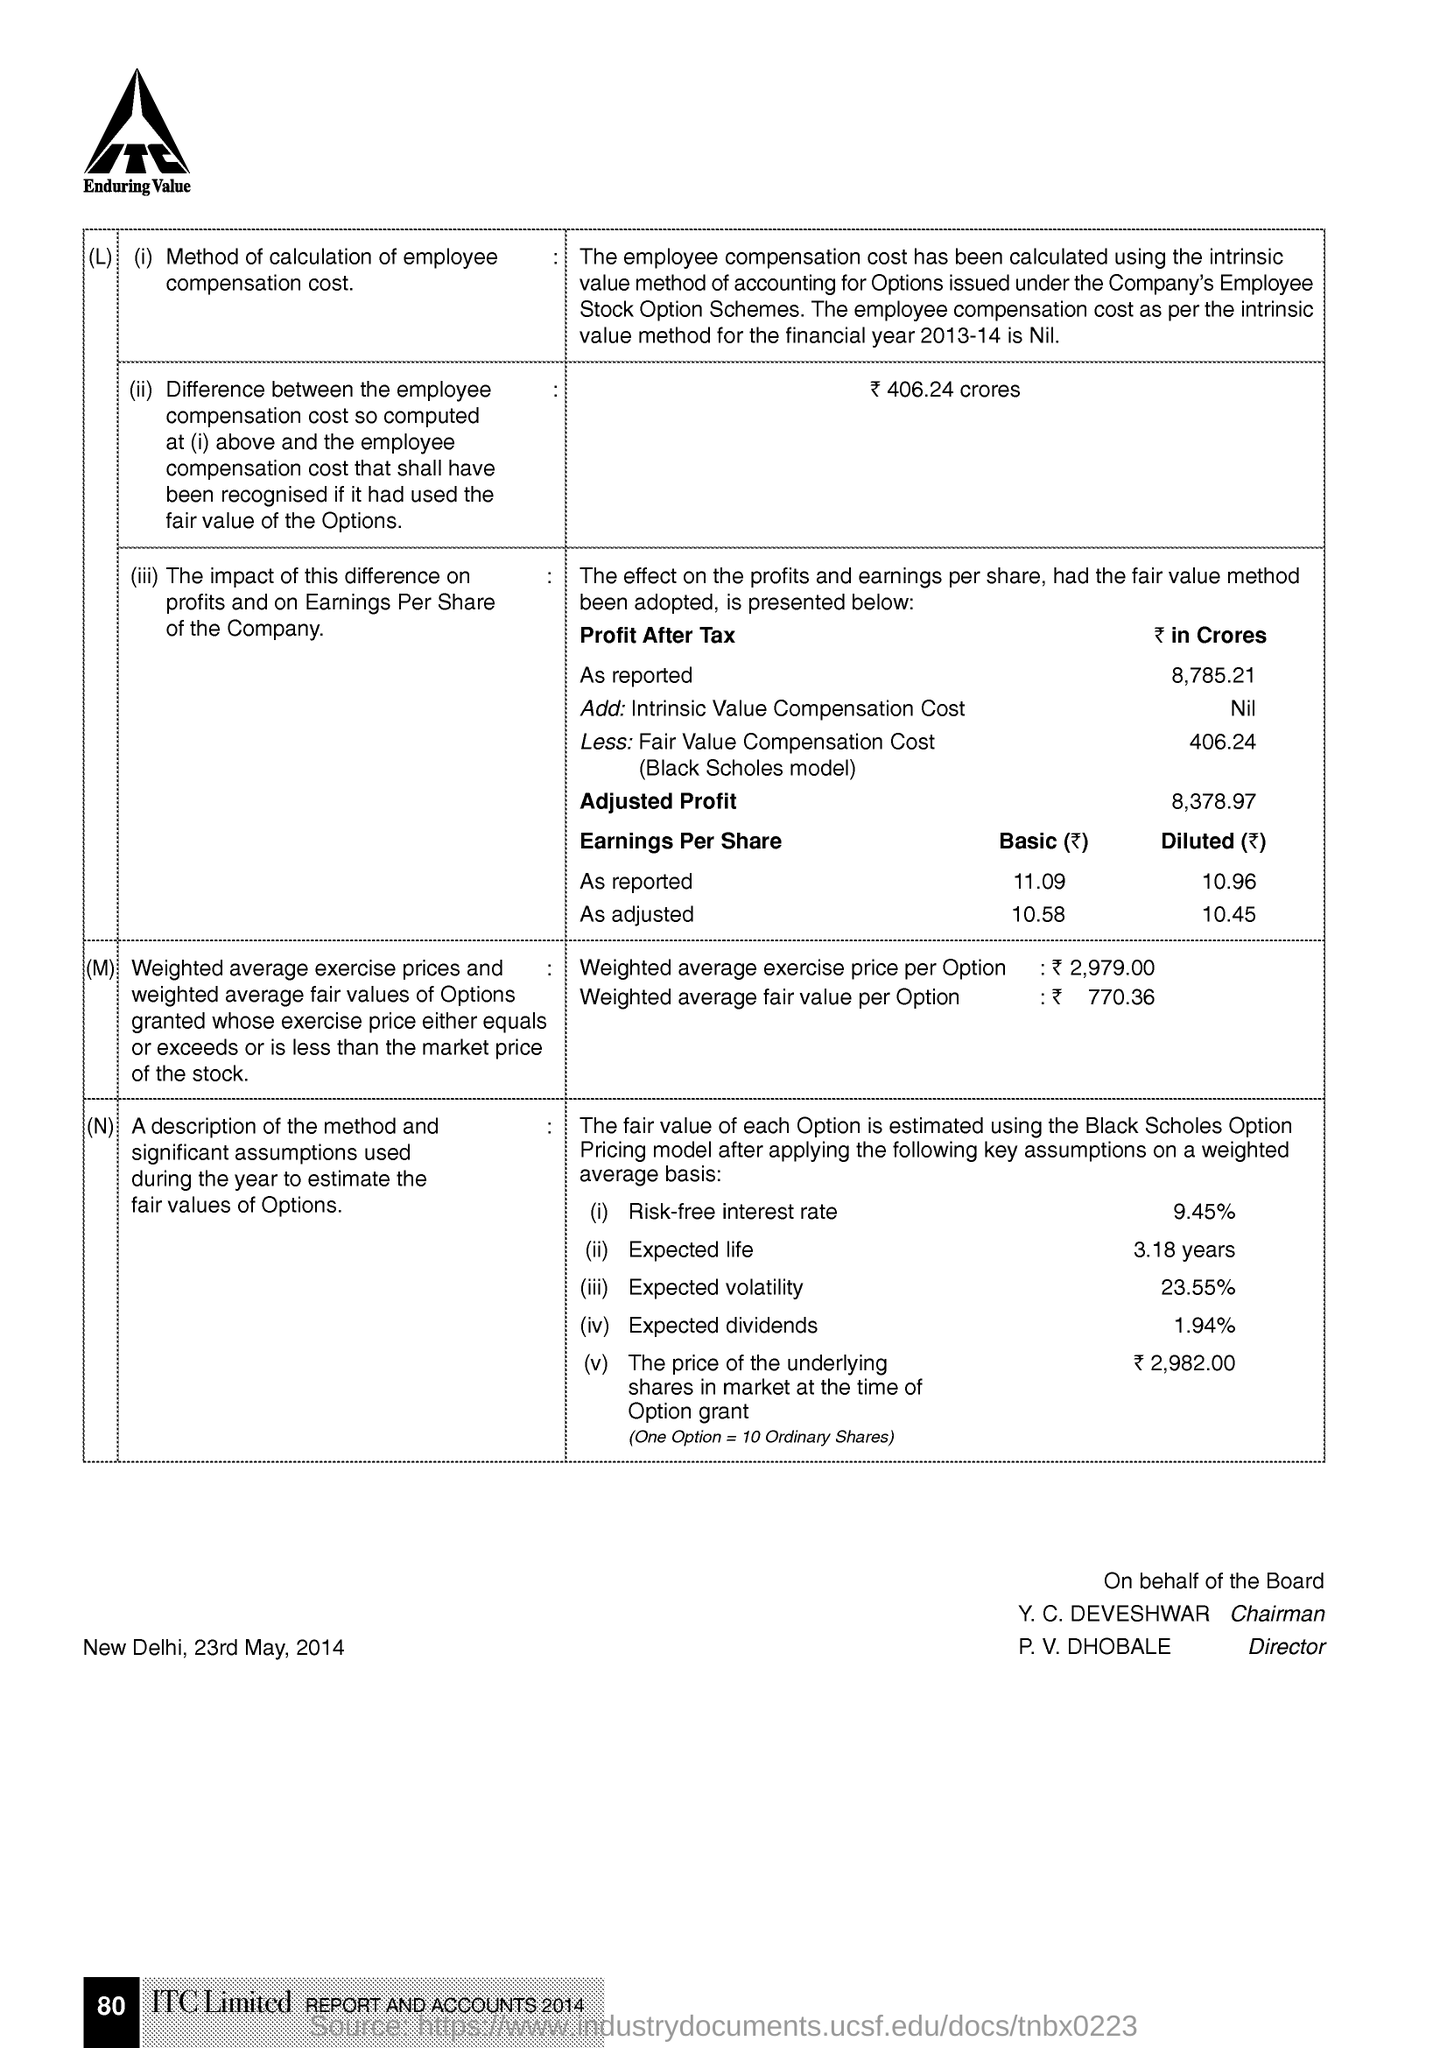Draw attention to some important aspects in this diagram. The document indicates that the place and date mentioned are New Delhi, May 23rd, 2014. The page number mentioned in this document is 80. 